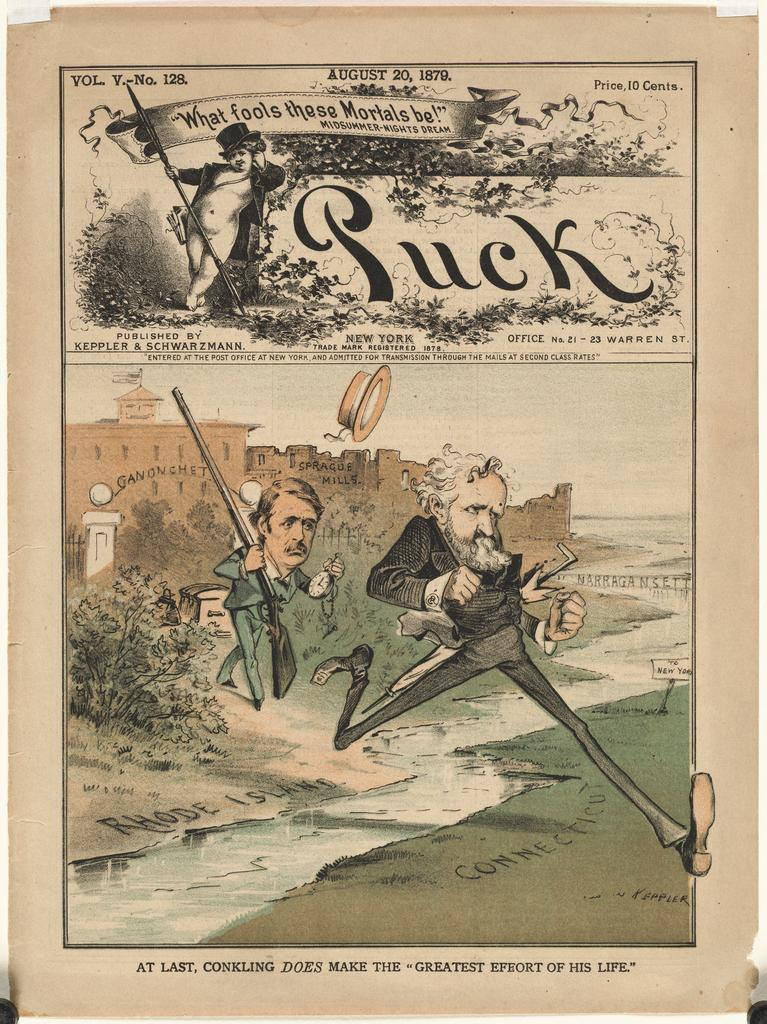<image>
Provide a brief description of the given image. A political cartoon with the word Puck at the top. 